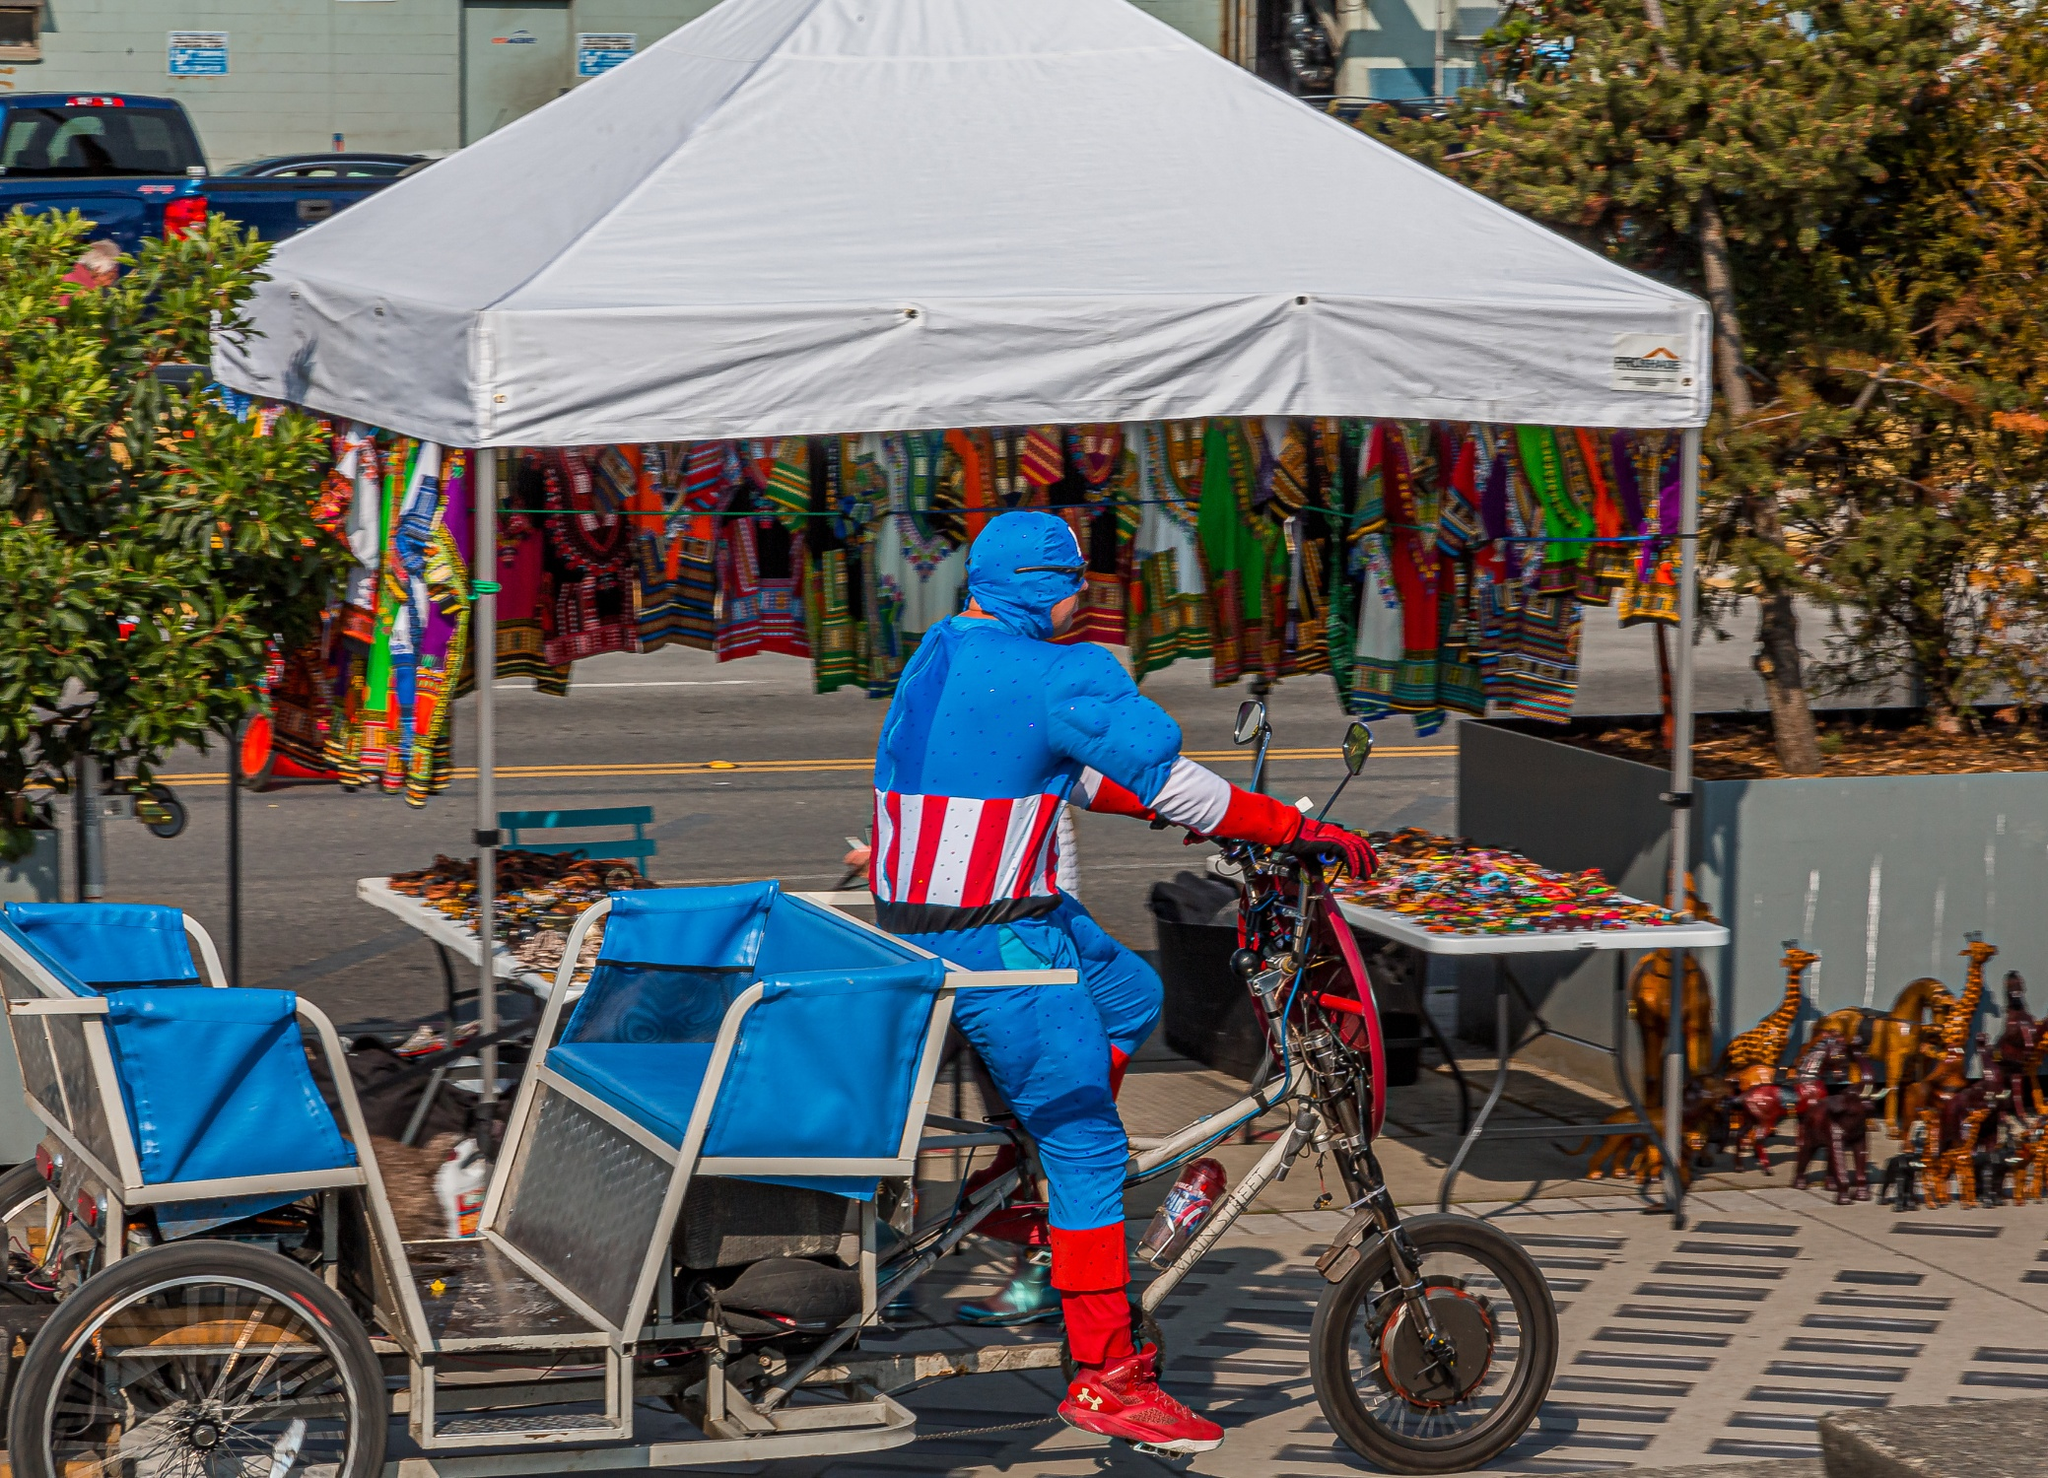Can you describe the main features of this image for me? The image features an individual dressed in a vibrant Captain America costume riding a bicycle. The costume is detailed with the iconic shield emblem on the back, and colors of red, white, and blue, mirroring the character's traditional outfit. The cyclist is pedaling a unique bicycle attached to a gray trailer, which hints at a possibly utilitarian use, perhaps in a parade or as part of a promotional event.

The surroundings reveal that this scene takes place in a lively area, likely a market or festive locality given the colorful displays under a white tent nearby, which sells various colorful items including clothing and accessories, adding a cultural dimension to the snapshot. Despite the busy background, the focus remains on the cyclist thanks to his distinctive and colorful attire. This setup portrays a fusion of daily urban life and playful costuming, blending the ordinary with the extraordinary. 